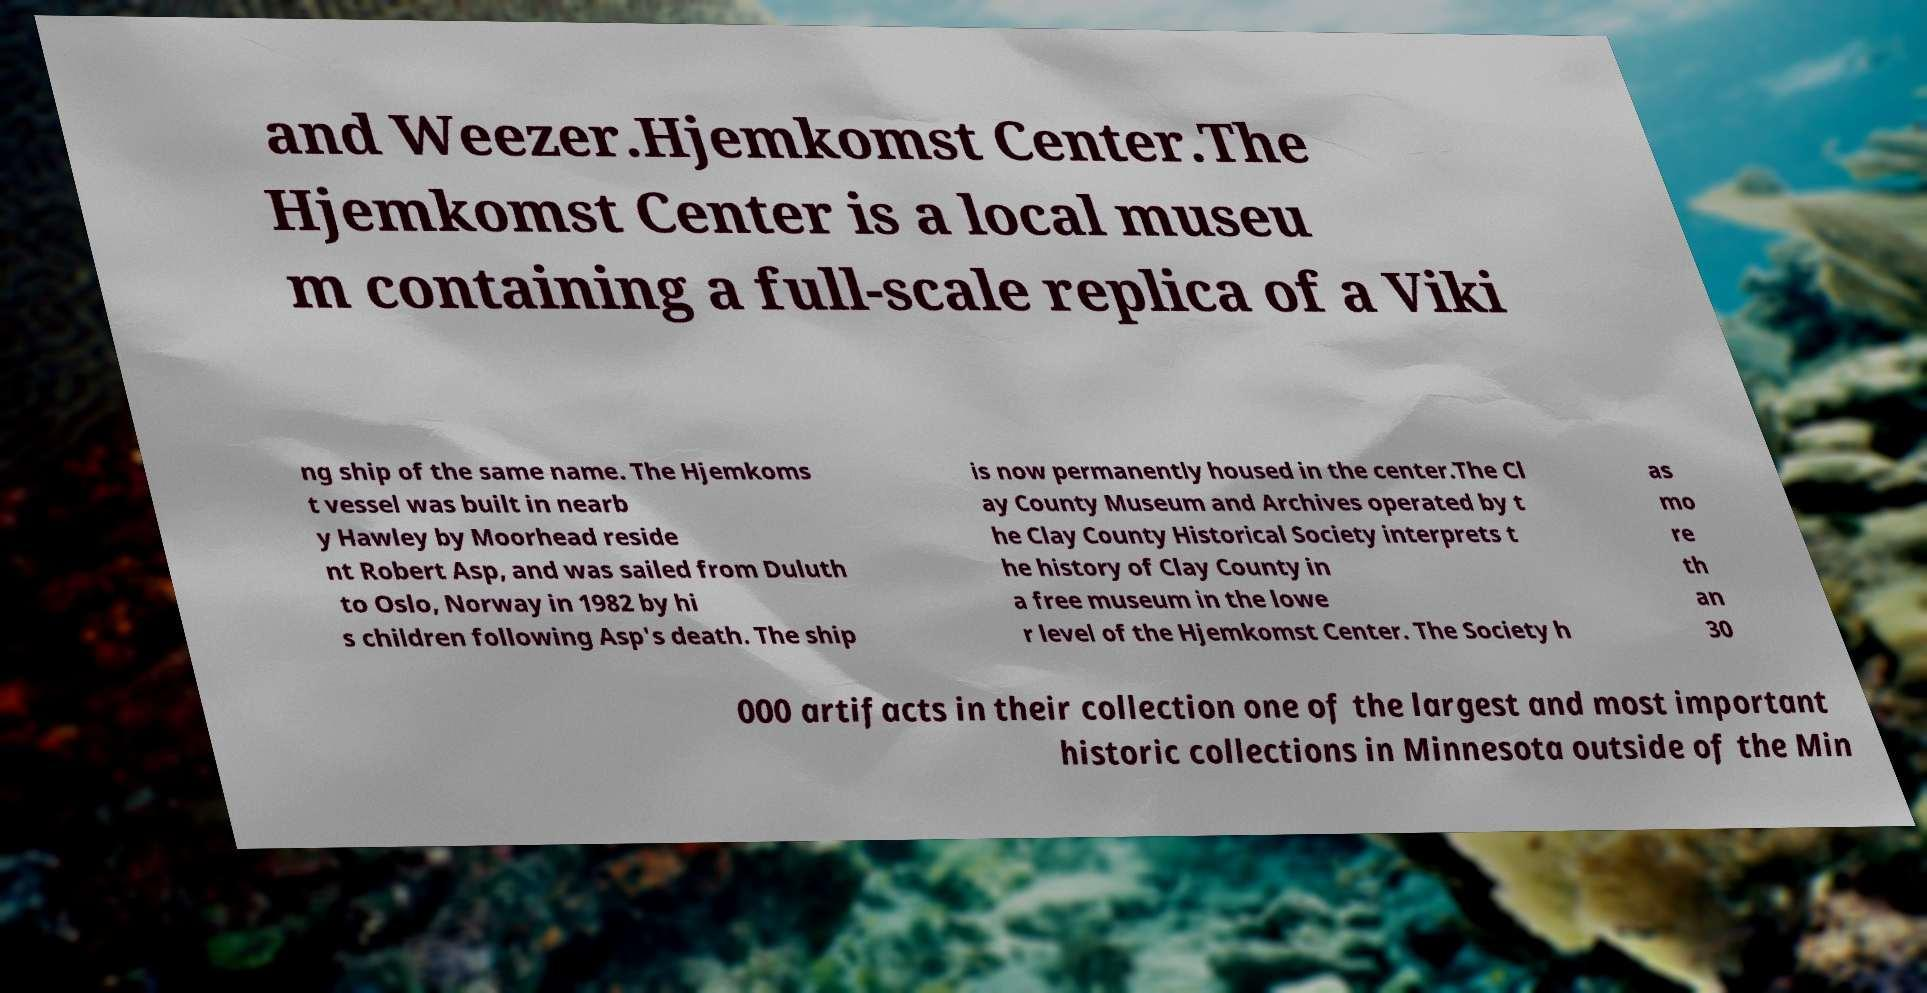Could you extract and type out the text from this image? and Weezer.Hjemkomst Center.The Hjemkomst Center is a local museu m containing a full-scale replica of a Viki ng ship of the same name. The Hjemkoms t vessel was built in nearb y Hawley by Moorhead reside nt Robert Asp, and was sailed from Duluth to Oslo, Norway in 1982 by hi s children following Asp's death. The ship is now permanently housed in the center.The Cl ay County Museum and Archives operated by t he Clay County Historical Society interprets t he history of Clay County in a free museum in the lowe r level of the Hjemkomst Center. The Society h as mo re th an 30 000 artifacts in their collection one of the largest and most important historic collections in Minnesota outside of the Min 